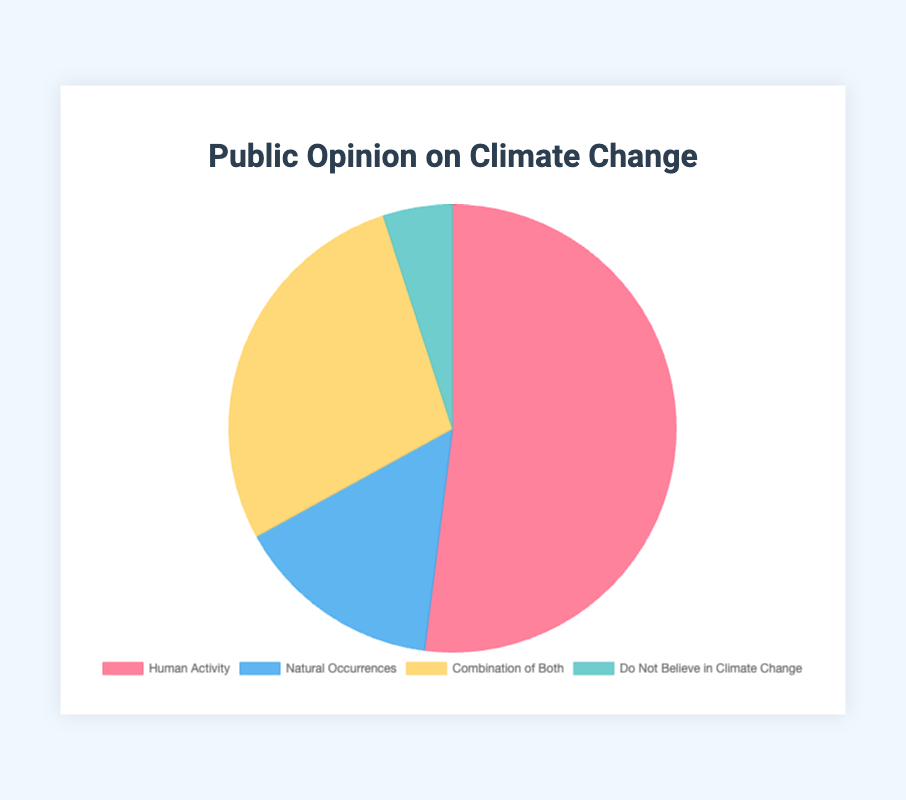What is the largest group represented in the chart? The largest group can be determined by looking at the percentages of each category. The category "Human Activity" has the highest percentage at 52%.
Answer: Human Activity What percentage of people believe climate change is caused by natural occurrences? Looking at the "Natural Occurrences" slice of the pie chart, it shows that 15% of people believe this.
Answer: 15% Which group believes that climate change is not happening at all, and what is their proportion? The "Do Not Believe in Climate Change" segment corresponds to people who don't believe in climate change, and the chart shows this segment is 5%.
Answer: Do Not Believe in Climate Change, 5% How many more people believe that climate change is due to "Human Activity" compared to "Natural Occurrences"? The difference in percentage between "Human Activity" (52%) and "Natural Occurrences" (15%) is calculated by subtracting the two values: 52% - 15% = 37%.
Answer: 37% Which group combines the belief in both human activity and natural occurrences, and what is their proportion? The label "Combination of Both" signifies a belief in both human activity and natural occurrences, accounting for 28% of people.
Answer: Combination of Both, 28% If you combine the groups that believe climate change is caused either by "Human Activity" or a "Combination of Both," what is their total percentage? Adding the percentage of "Human Activity" (52%) and "Combination of Both" (28%) yields a total of 52% + 28% = 80%.
Answer: 80% What is the difference in percentage between the smallest group and the largest group? The smallest group is "Do Not Believe in Climate Change" with 5%, and the largest is "Human Activity" with 52%. The difference is 52% - 5% = 47%.
Answer: 47% How much more prevalent is the belief that climate change is caused by a combination of both human activity and natural occurrences than the belief that it is caused by natural occurrences alone? The percentage for "Combination of Both" is 28%, while for "Natural Occurrences" it is 15%. The difference is 28% - 15% = 13%.
Answer: 13% What color represents the category "Natural Occurrences"? The pie chart uses visual colors to represent the different categories. The "Natural Occurrences" section is represented in blue.
Answer: Blue If the total number of respondents is 1000, approximately how many people do not believe in climate change? Given that 5% of respondents do not believe in climate change, we multiply 5% by the total number (1000): 0.05 * 1000 = 50.
Answer: 50 